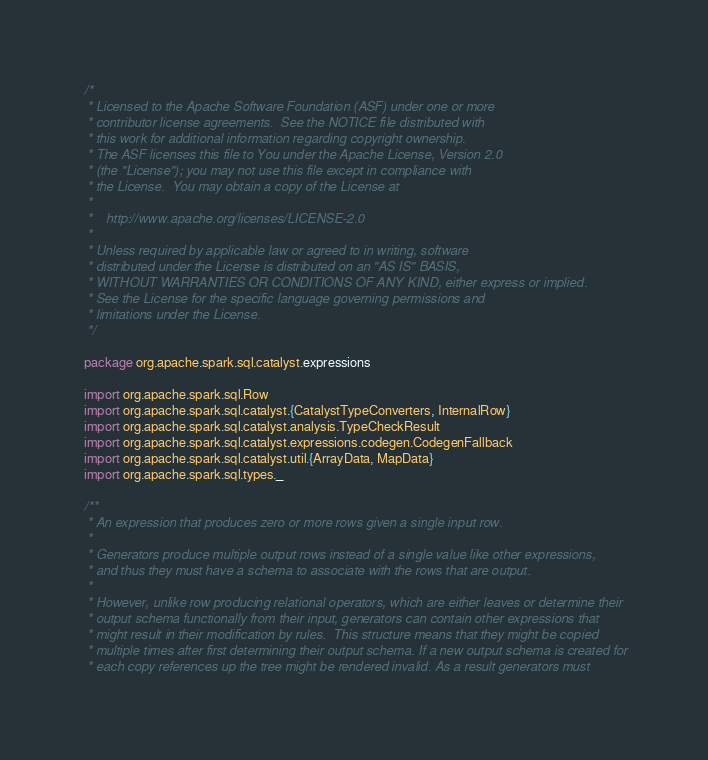<code> <loc_0><loc_0><loc_500><loc_500><_Scala_>/*
 * Licensed to the Apache Software Foundation (ASF) under one or more
 * contributor license agreements.  See the NOTICE file distributed with
 * this work for additional information regarding copyright ownership.
 * The ASF licenses this file to You under the Apache License, Version 2.0
 * (the "License"); you may not use this file except in compliance with
 * the License.  You may obtain a copy of the License at
 *
 *    http://www.apache.org/licenses/LICENSE-2.0
 *
 * Unless required by applicable law or agreed to in writing, software
 * distributed under the License is distributed on an "AS IS" BASIS,
 * WITHOUT WARRANTIES OR CONDITIONS OF ANY KIND, either express or implied.
 * See the License for the specific language governing permissions and
 * limitations under the License.
 */

package org.apache.spark.sql.catalyst.expressions

import org.apache.spark.sql.Row
import org.apache.spark.sql.catalyst.{CatalystTypeConverters, InternalRow}
import org.apache.spark.sql.catalyst.analysis.TypeCheckResult
import org.apache.spark.sql.catalyst.expressions.codegen.CodegenFallback
import org.apache.spark.sql.catalyst.util.{ArrayData, MapData}
import org.apache.spark.sql.types._

/**
 * An expression that produces zero or more rows given a single input row.
 *
 * Generators produce multiple output rows instead of a single value like other expressions,
 * and thus they must have a schema to associate with the rows that are output.
 *
 * However, unlike row producing relational operators, which are either leaves or determine their
 * output schema functionally from their input, generators can contain other expressions that
 * might result in their modification by rules.  This structure means that they might be copied
 * multiple times after first determining their output schema. If a new output schema is created for
 * each copy references up the tree might be rendered invalid. As a result generators must</code> 